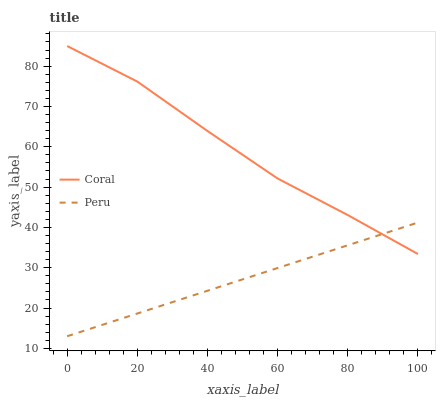Does Peru have the minimum area under the curve?
Answer yes or no. Yes. Does Coral have the maximum area under the curve?
Answer yes or no. Yes. Does Peru have the maximum area under the curve?
Answer yes or no. No. Is Peru the smoothest?
Answer yes or no. Yes. Is Coral the roughest?
Answer yes or no. Yes. Is Peru the roughest?
Answer yes or no. No. Does Peru have the lowest value?
Answer yes or no. Yes. Does Coral have the highest value?
Answer yes or no. Yes. Does Peru have the highest value?
Answer yes or no. No. Does Coral intersect Peru?
Answer yes or no. Yes. Is Coral less than Peru?
Answer yes or no. No. Is Coral greater than Peru?
Answer yes or no. No. 